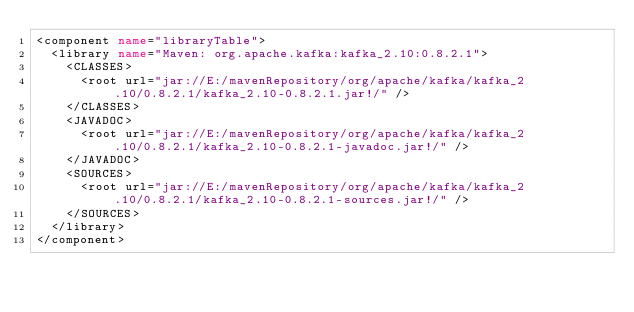Convert code to text. <code><loc_0><loc_0><loc_500><loc_500><_XML_><component name="libraryTable">
  <library name="Maven: org.apache.kafka:kafka_2.10:0.8.2.1">
    <CLASSES>
      <root url="jar://E:/mavenRepository/org/apache/kafka/kafka_2.10/0.8.2.1/kafka_2.10-0.8.2.1.jar!/" />
    </CLASSES>
    <JAVADOC>
      <root url="jar://E:/mavenRepository/org/apache/kafka/kafka_2.10/0.8.2.1/kafka_2.10-0.8.2.1-javadoc.jar!/" />
    </JAVADOC>
    <SOURCES>
      <root url="jar://E:/mavenRepository/org/apache/kafka/kafka_2.10/0.8.2.1/kafka_2.10-0.8.2.1-sources.jar!/" />
    </SOURCES>
  </library>
</component></code> 